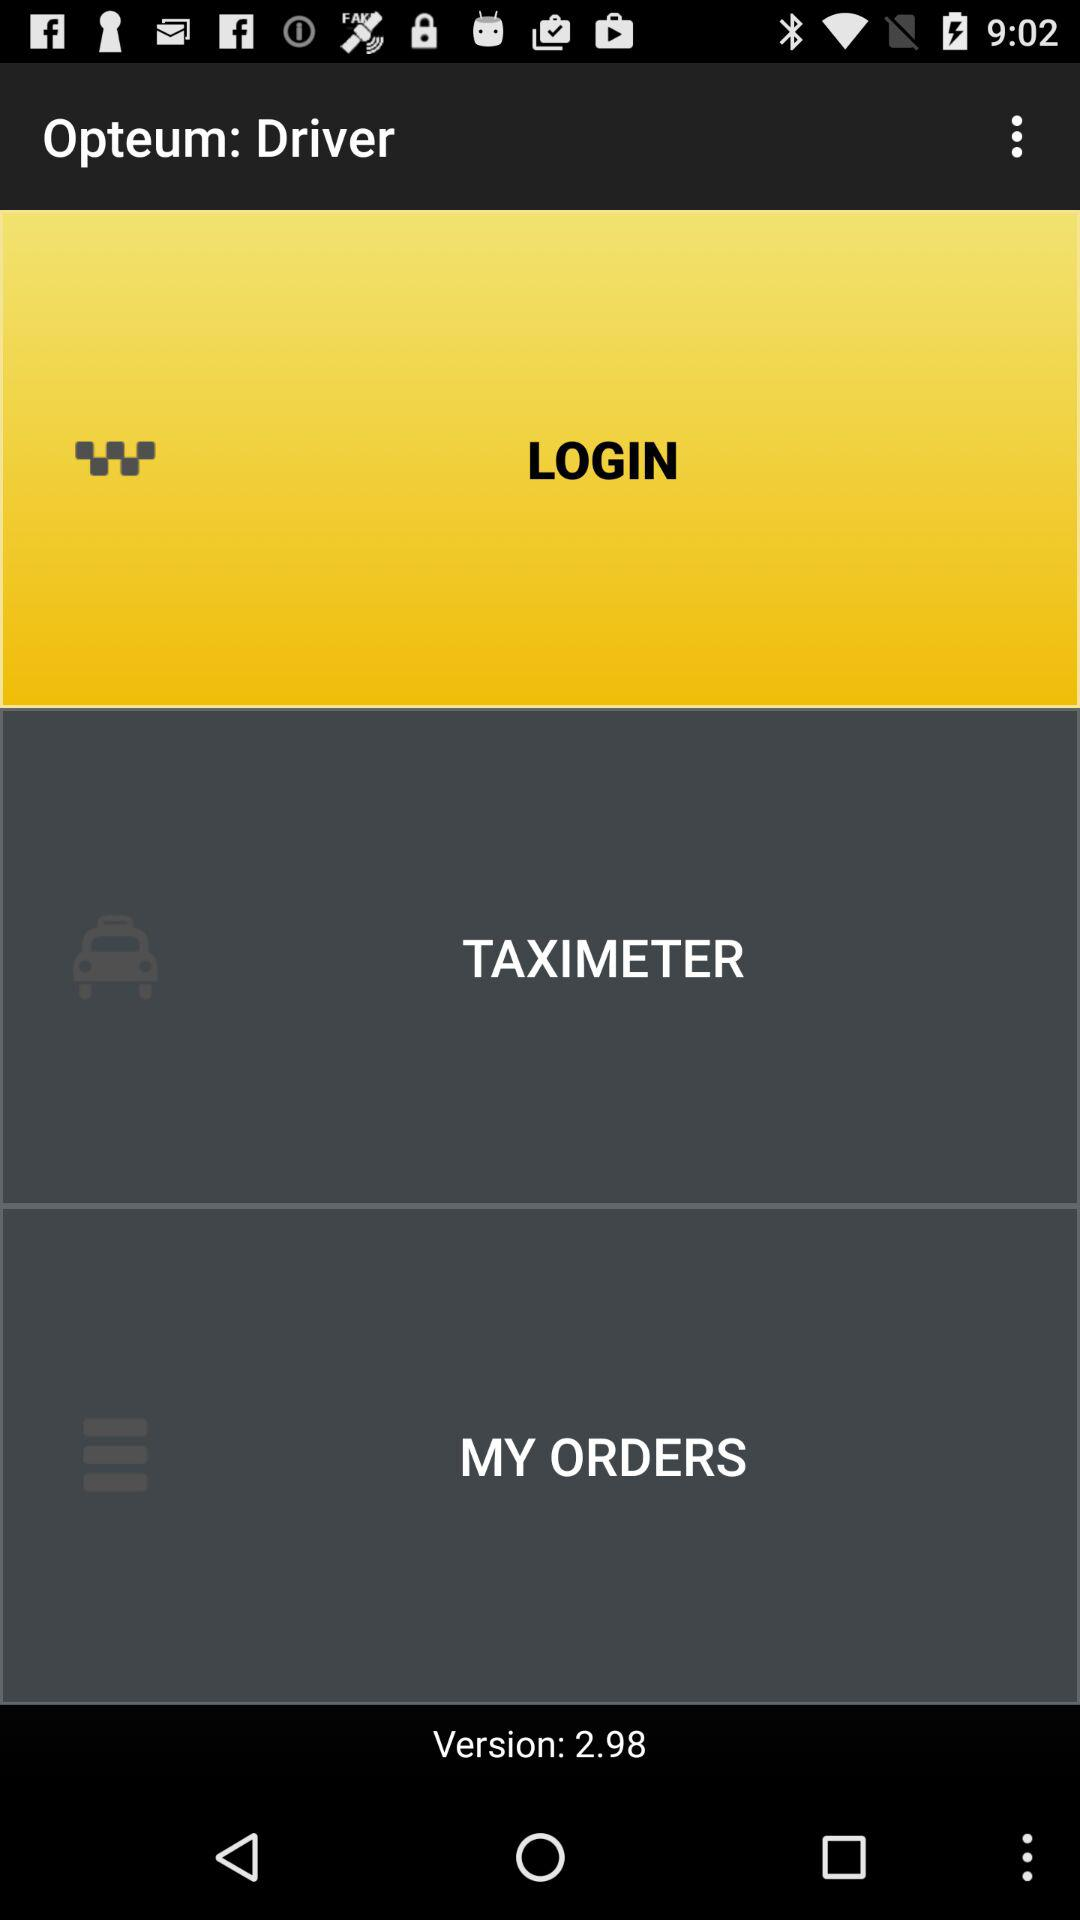What is the version of the app? The version of the app is 2.98. 